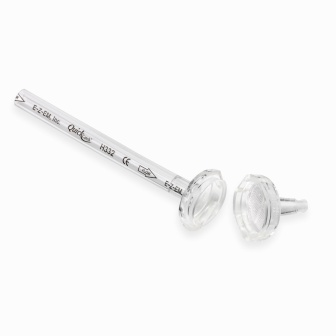What's happening in the scene? The image showcases a unique rod made of silver-colored metal, displayed against a white background. At each end of the rod, there are clear plastic knobs with faceted designs, adding a touch of elegance to its appearance. The rod itself features precise engravings: 'Esker' and 'Pride' on one side, and 'H42' and 'Esker' on the other. These engravings are prominently visible, thanks to the high contrast between the bright and reflective rod and the stark white background. This intriguing object not only stands out due to its aesthetic design but also sparks curiosity about its purpose, origin, and the story behind the etched words. 